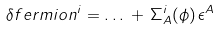<formula> <loc_0><loc_0><loc_500><loc_500>\delta f e r m i o n ^ { i } = \dots \, + \, \Sigma _ { A } ^ { i } ( \phi ) \, \epsilon ^ { A }</formula> 